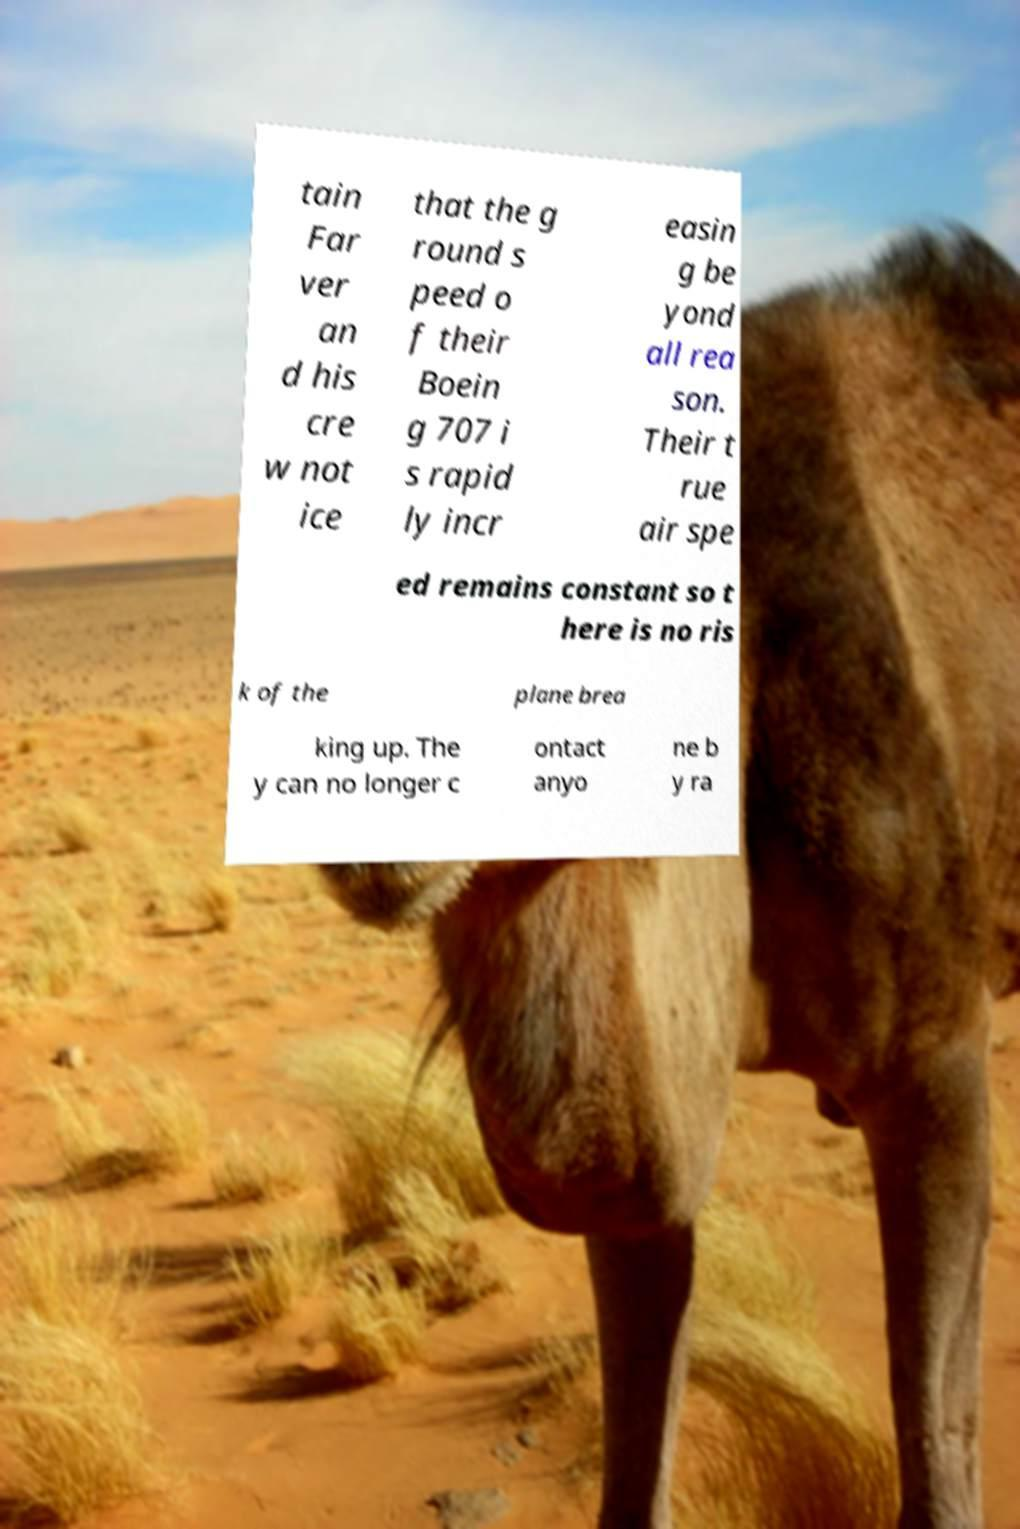Could you extract and type out the text from this image? tain Far ver an d his cre w not ice that the g round s peed o f their Boein g 707 i s rapid ly incr easin g be yond all rea son. Their t rue air spe ed remains constant so t here is no ris k of the plane brea king up. The y can no longer c ontact anyo ne b y ra 